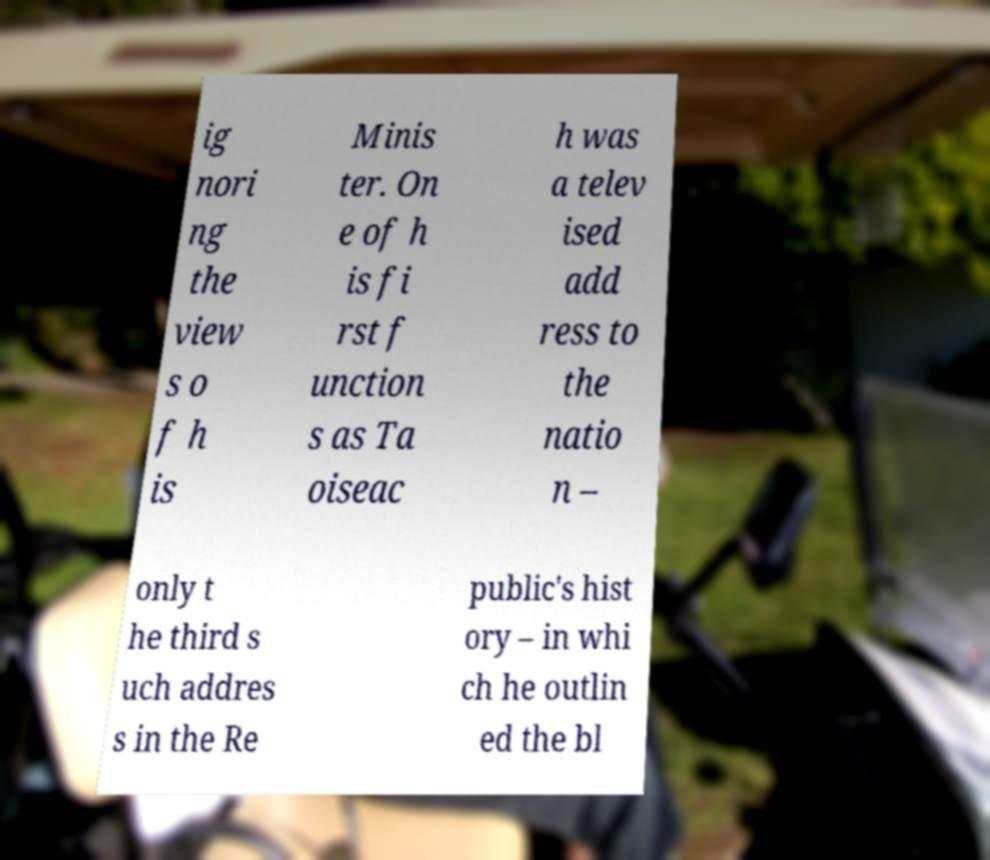Can you accurately transcribe the text from the provided image for me? ig nori ng the view s o f h is Minis ter. On e of h is fi rst f unction s as Ta oiseac h was a telev ised add ress to the natio n – only t he third s uch addres s in the Re public's hist ory – in whi ch he outlin ed the bl 